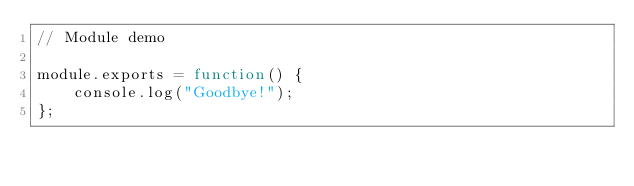<code> <loc_0><loc_0><loc_500><loc_500><_JavaScript_>// Module demo

module.exports = function() {
    console.log("Goodbye!");
};</code> 